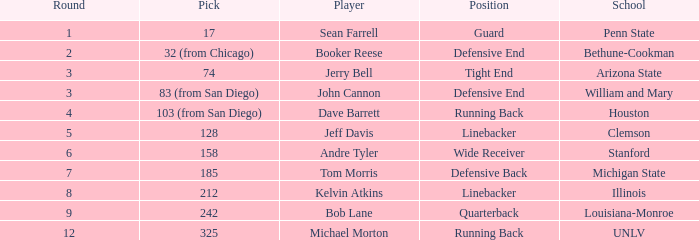Which round did tom morris get chosen in? 1.0. I'm looking to parse the entire table for insights. Could you assist me with that? {'header': ['Round', 'Pick', 'Player', 'Position', 'School'], 'rows': [['1', '17', 'Sean Farrell', 'Guard', 'Penn State'], ['2', '32 (from Chicago)', 'Booker Reese', 'Defensive End', 'Bethune-Cookman'], ['3', '74', 'Jerry Bell', 'Tight End', 'Arizona State'], ['3', '83 (from San Diego)', 'John Cannon', 'Defensive End', 'William and Mary'], ['4', '103 (from San Diego)', 'Dave Barrett', 'Running Back', 'Houston'], ['5', '128', 'Jeff Davis', 'Linebacker', 'Clemson'], ['6', '158', 'Andre Tyler', 'Wide Receiver', 'Stanford'], ['7', '185', 'Tom Morris', 'Defensive Back', 'Michigan State'], ['8', '212', 'Kelvin Atkins', 'Linebacker', 'Illinois'], ['9', '242', 'Bob Lane', 'Quarterback', 'Louisiana-Monroe'], ['12', '325', 'Michael Morton', 'Running Back', 'UNLV']]} 